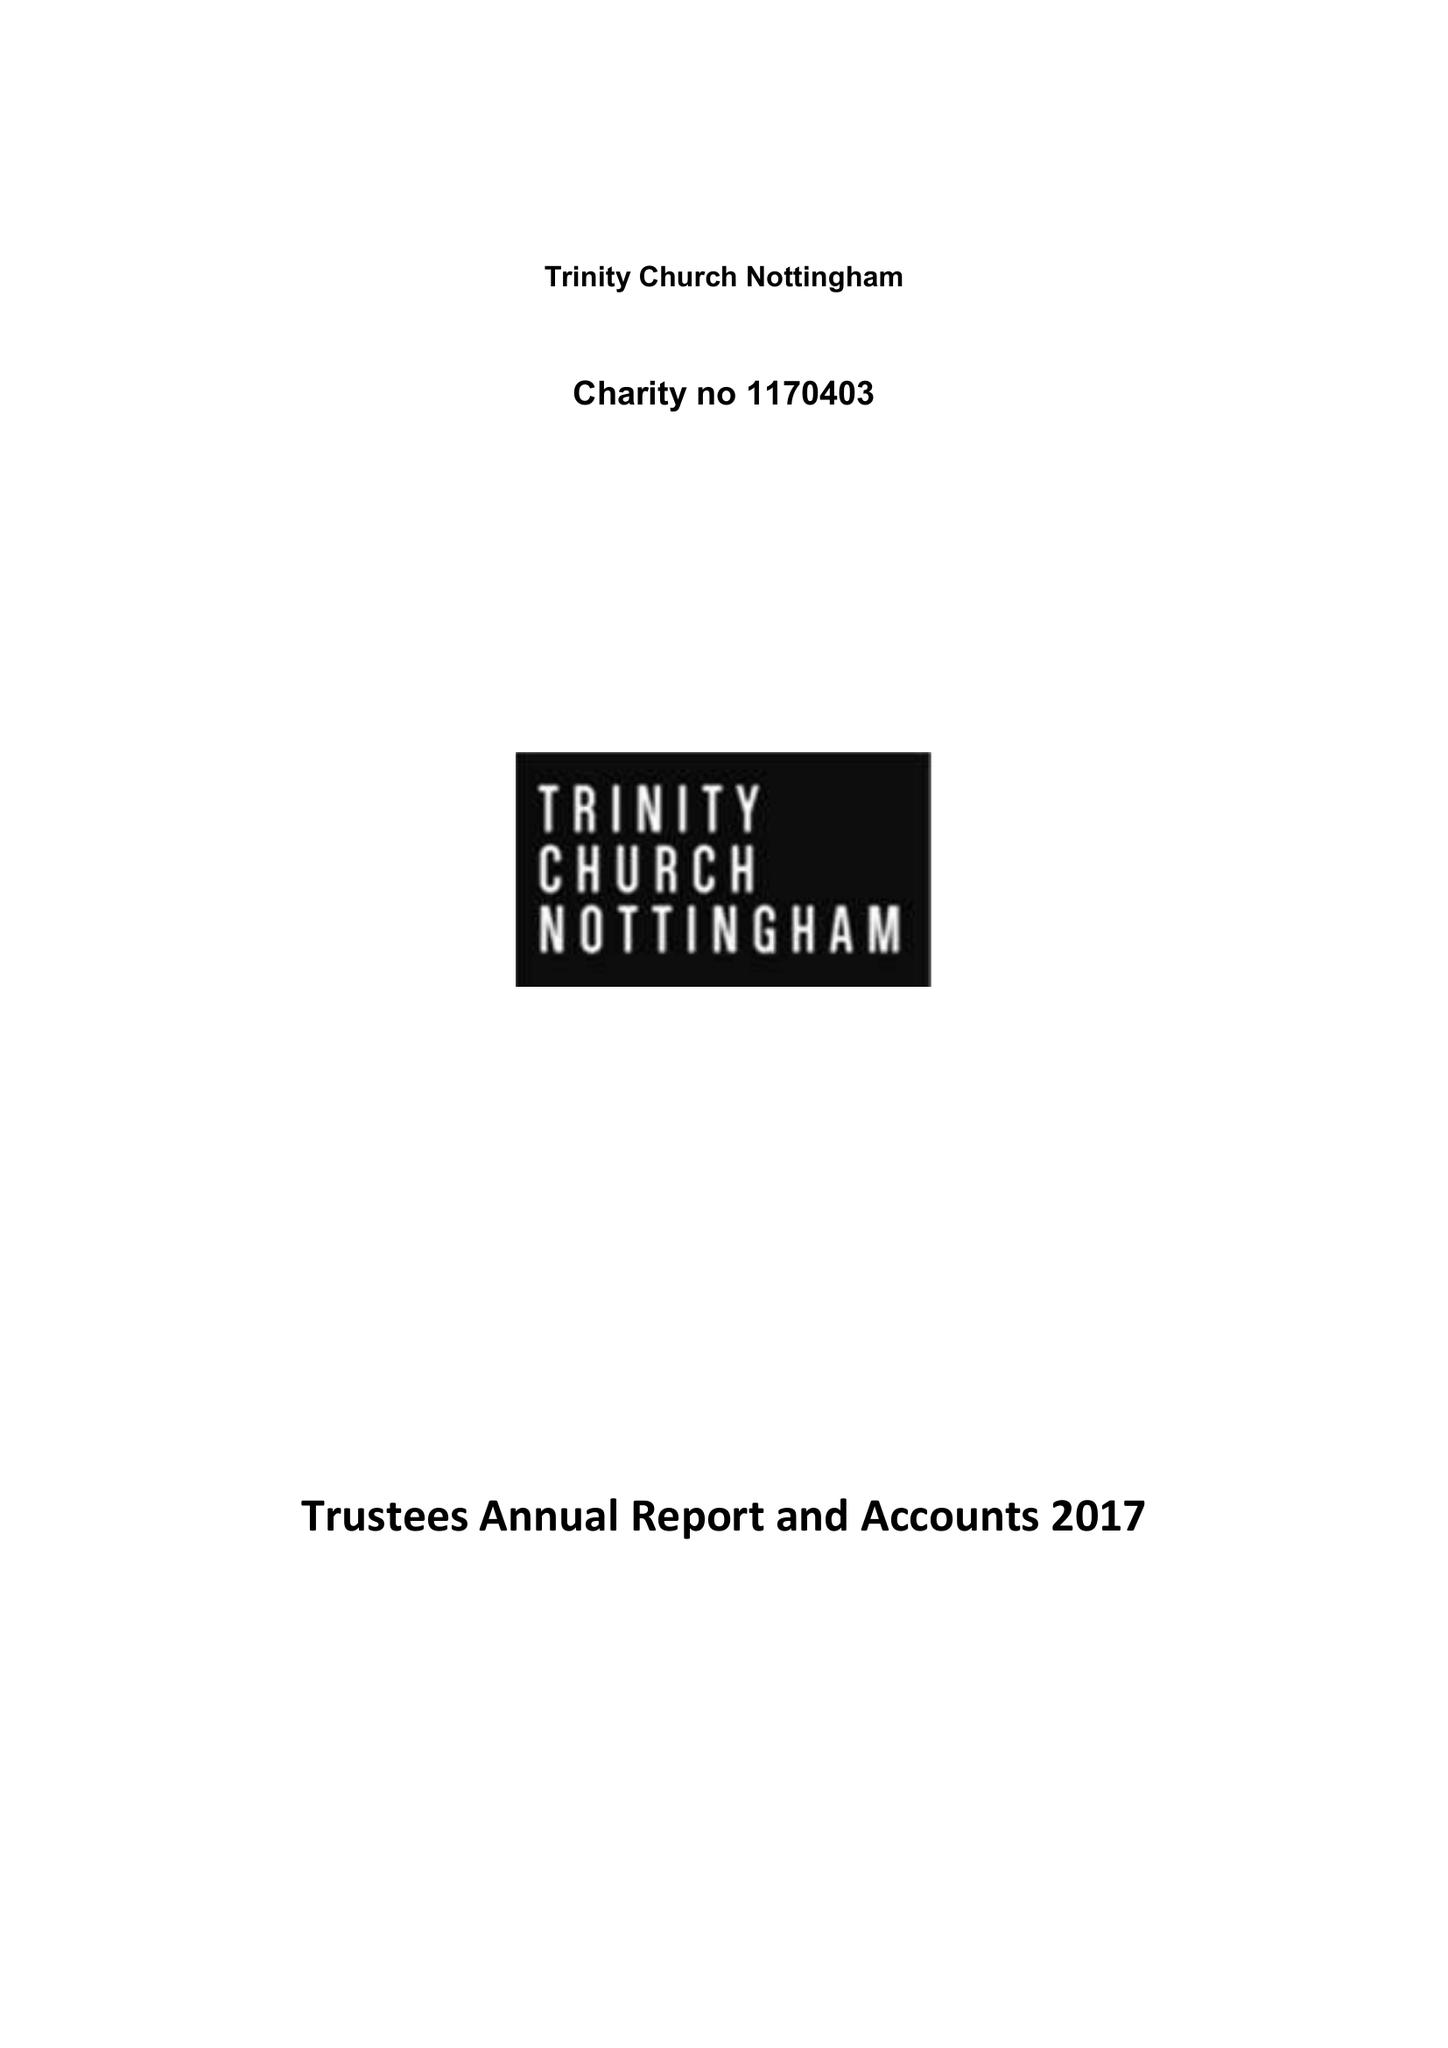What is the value for the address__post_town?
Answer the question using a single word or phrase. NOTTINGHAM 